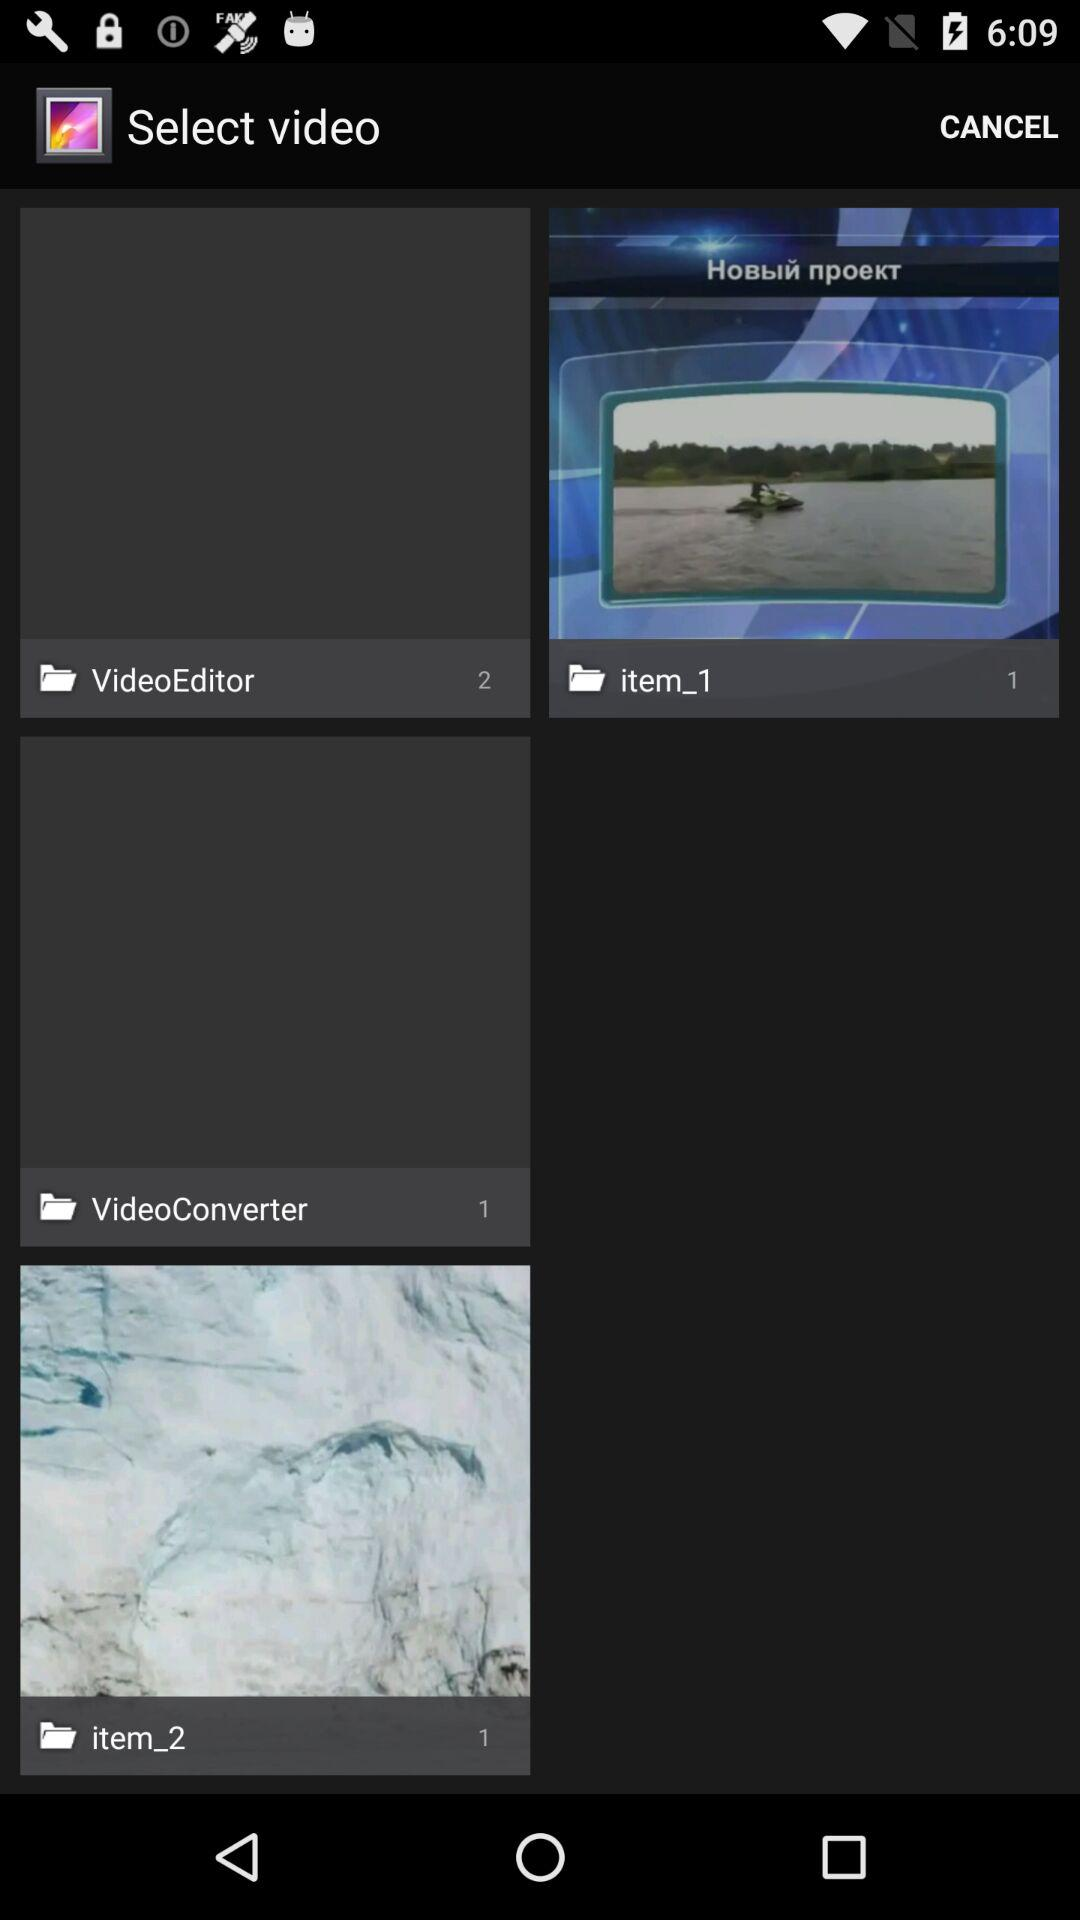How many images are there in the "VideoConverter" album? There is 1 image in the "VideoConverter" album. 